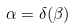<formula> <loc_0><loc_0><loc_500><loc_500>\alpha = \delta ( \beta )</formula> 